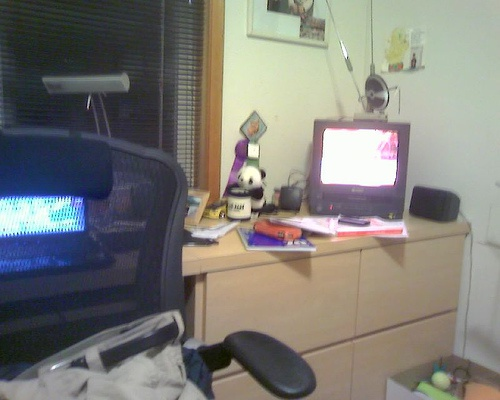Describe the objects in this image and their specific colors. I can see chair in black, navy, gray, and blue tones, tv in black, white, and gray tones, laptop in black, navy, lightblue, blue, and cyan tones, chair in black and gray tones, and teddy bear in black, beige, darkgray, and gray tones in this image. 